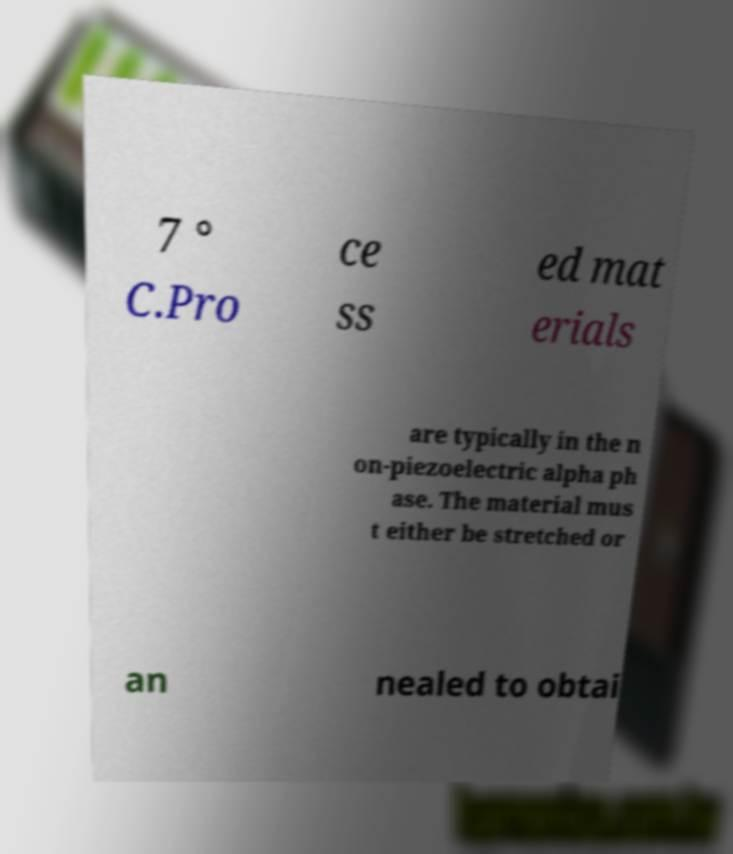Could you assist in decoding the text presented in this image and type it out clearly? 7 ° C.Pro ce ss ed mat erials are typically in the n on-piezoelectric alpha ph ase. The material mus t either be stretched or an nealed to obtai 